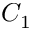<formula> <loc_0><loc_0><loc_500><loc_500>C _ { 1 }</formula> 